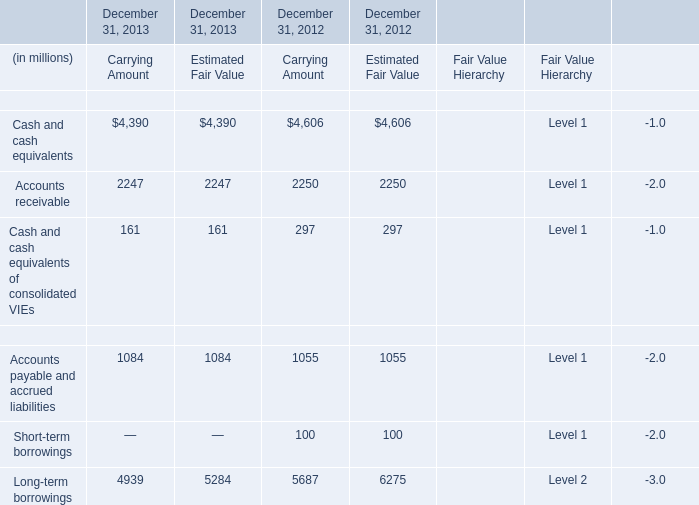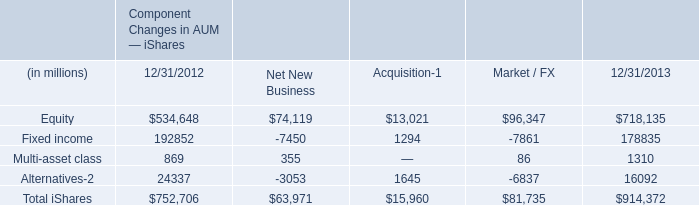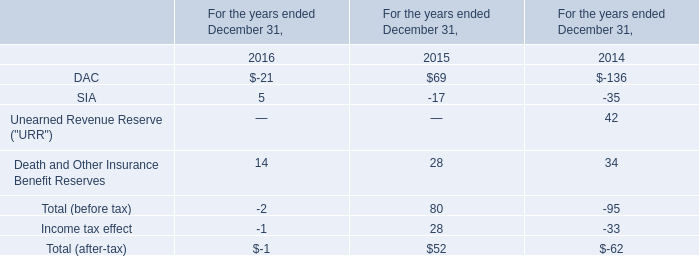What's the total amount of the financial liabilities in carrying amount in the years where Cash and cash equivalents of consolidated VIEs is greater than 200? (in million) 
Computations: ((1055 + 100) + 5687)
Answer: 6842.0. 